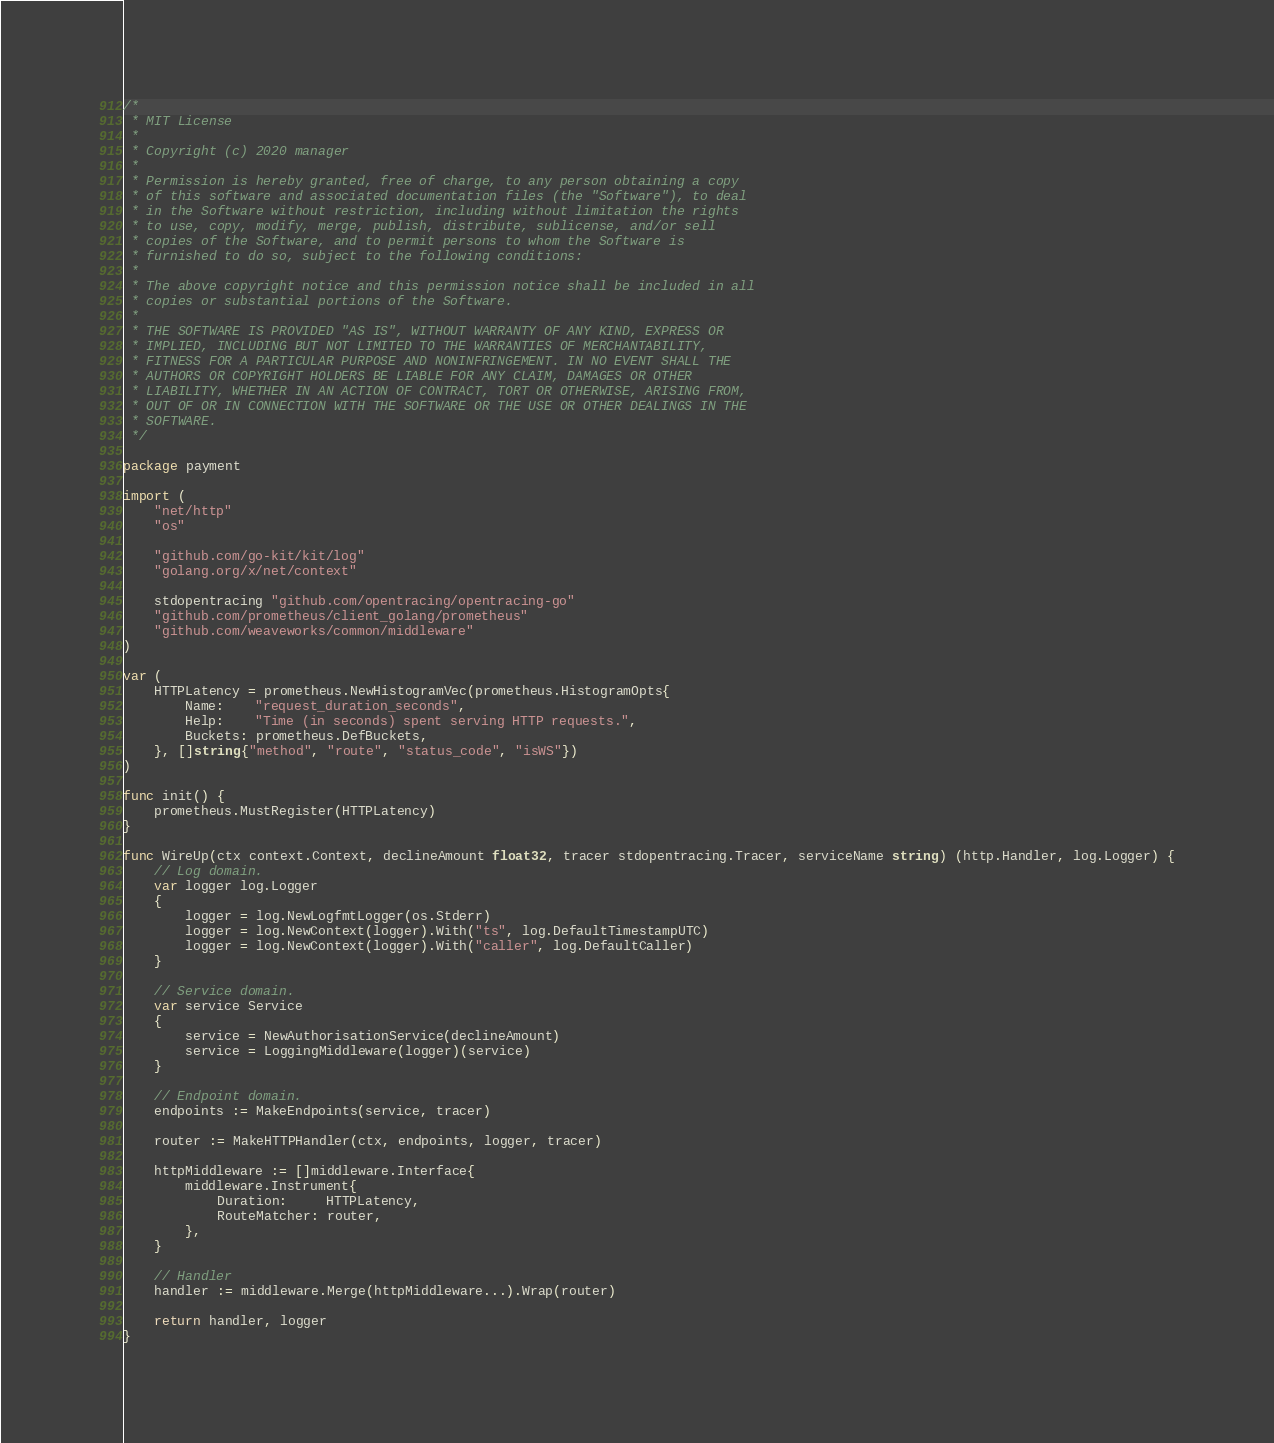Convert code to text. <code><loc_0><loc_0><loc_500><loc_500><_Go_>/*
 * MIT License
 *
 * Copyright (c) 2020 manager
 *
 * Permission is hereby granted, free of charge, to any person obtaining a copy
 * of this software and associated documentation files (the "Software"), to deal
 * in the Software without restriction, including without limitation the rights
 * to use, copy, modify, merge, publish, distribute, sublicense, and/or sell
 * copies of the Software, and to permit persons to whom the Software is
 * furnished to do so, subject to the following conditions:
 *
 * The above copyright notice and this permission notice shall be included in all
 * copies or substantial portions of the Software.
 *
 * THE SOFTWARE IS PROVIDED "AS IS", WITHOUT WARRANTY OF ANY KIND, EXPRESS OR
 * IMPLIED, INCLUDING BUT NOT LIMITED TO THE WARRANTIES OF MERCHANTABILITY,
 * FITNESS FOR A PARTICULAR PURPOSE AND NONINFRINGEMENT. IN NO EVENT SHALL THE
 * AUTHORS OR COPYRIGHT HOLDERS BE LIABLE FOR ANY CLAIM, DAMAGES OR OTHER
 * LIABILITY, WHETHER IN AN ACTION OF CONTRACT, TORT OR OTHERWISE, ARISING FROM,
 * OUT OF OR IN CONNECTION WITH THE SOFTWARE OR THE USE OR OTHER DEALINGS IN THE
 * SOFTWARE.
 */

package payment

import (
	"net/http"
	"os"

	"github.com/go-kit/kit/log"
	"golang.org/x/net/context"

	stdopentracing "github.com/opentracing/opentracing-go"
	"github.com/prometheus/client_golang/prometheus"
	"github.com/weaveworks/common/middleware"
)

var (
	HTTPLatency = prometheus.NewHistogramVec(prometheus.HistogramOpts{
		Name:    "request_duration_seconds",
		Help:    "Time (in seconds) spent serving HTTP requests.",
		Buckets: prometheus.DefBuckets,
	}, []string{"method", "route", "status_code", "isWS"})
)

func init() {
	prometheus.MustRegister(HTTPLatency)
}

func WireUp(ctx context.Context, declineAmount float32, tracer stdopentracing.Tracer, serviceName string) (http.Handler, log.Logger) {
	// Log domain.
	var logger log.Logger
	{
		logger = log.NewLogfmtLogger(os.Stderr)
		logger = log.NewContext(logger).With("ts", log.DefaultTimestampUTC)
		logger = log.NewContext(logger).With("caller", log.DefaultCaller)
	}

	// Service domain.
	var service Service
	{
		service = NewAuthorisationService(declineAmount)
		service = LoggingMiddleware(logger)(service)
	}

	// Endpoint domain.
	endpoints := MakeEndpoints(service, tracer)

	router := MakeHTTPHandler(ctx, endpoints, logger, tracer)

	httpMiddleware := []middleware.Interface{
		middleware.Instrument{
			Duration:     HTTPLatency,
			RouteMatcher: router,
		},
	}

	// Handler
	handler := middleware.Merge(httpMiddleware...).Wrap(router)

	return handler, logger
}
</code> 